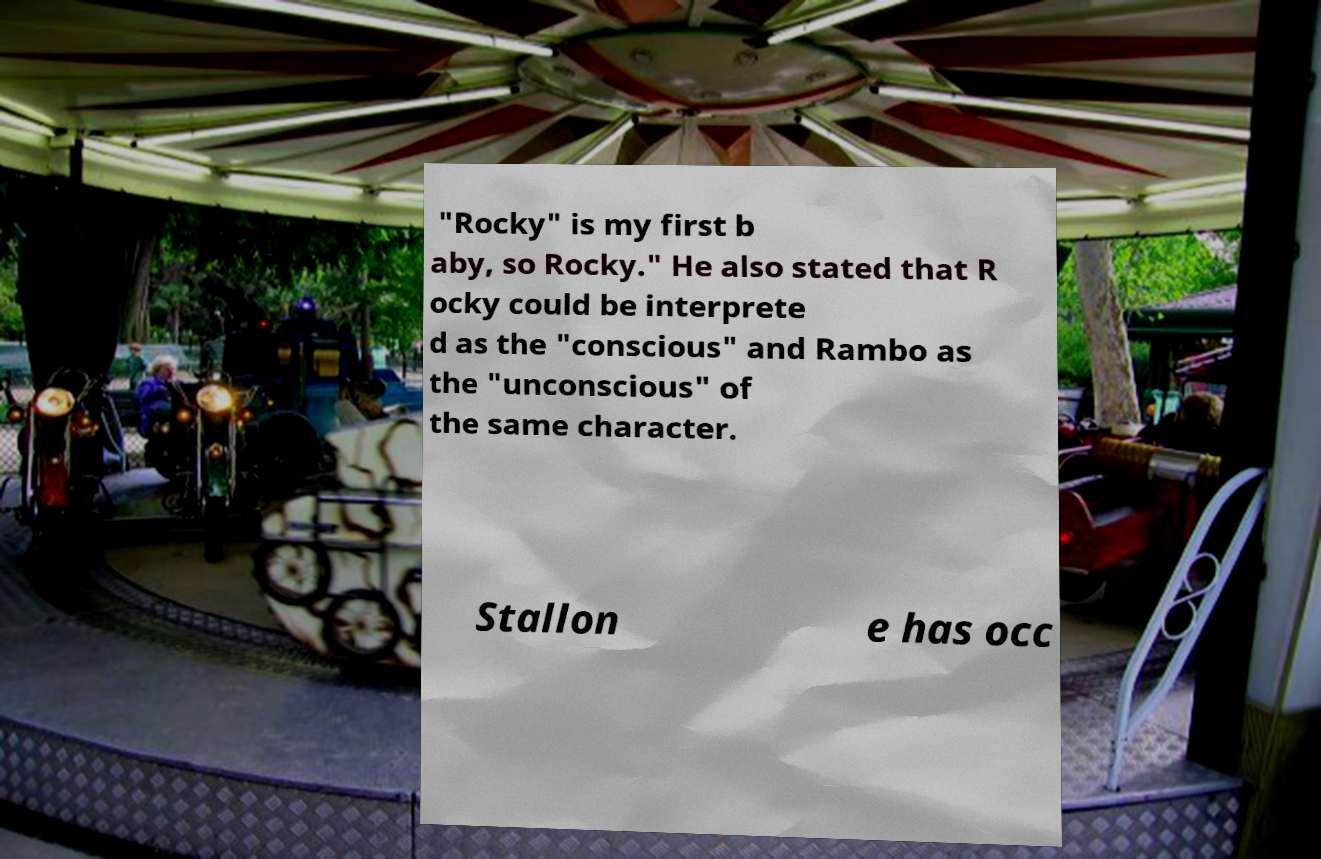For documentation purposes, I need the text within this image transcribed. Could you provide that? "Rocky" is my first b aby, so Rocky." He also stated that R ocky could be interprete d as the "conscious" and Rambo as the "unconscious" of the same character. Stallon e has occ 